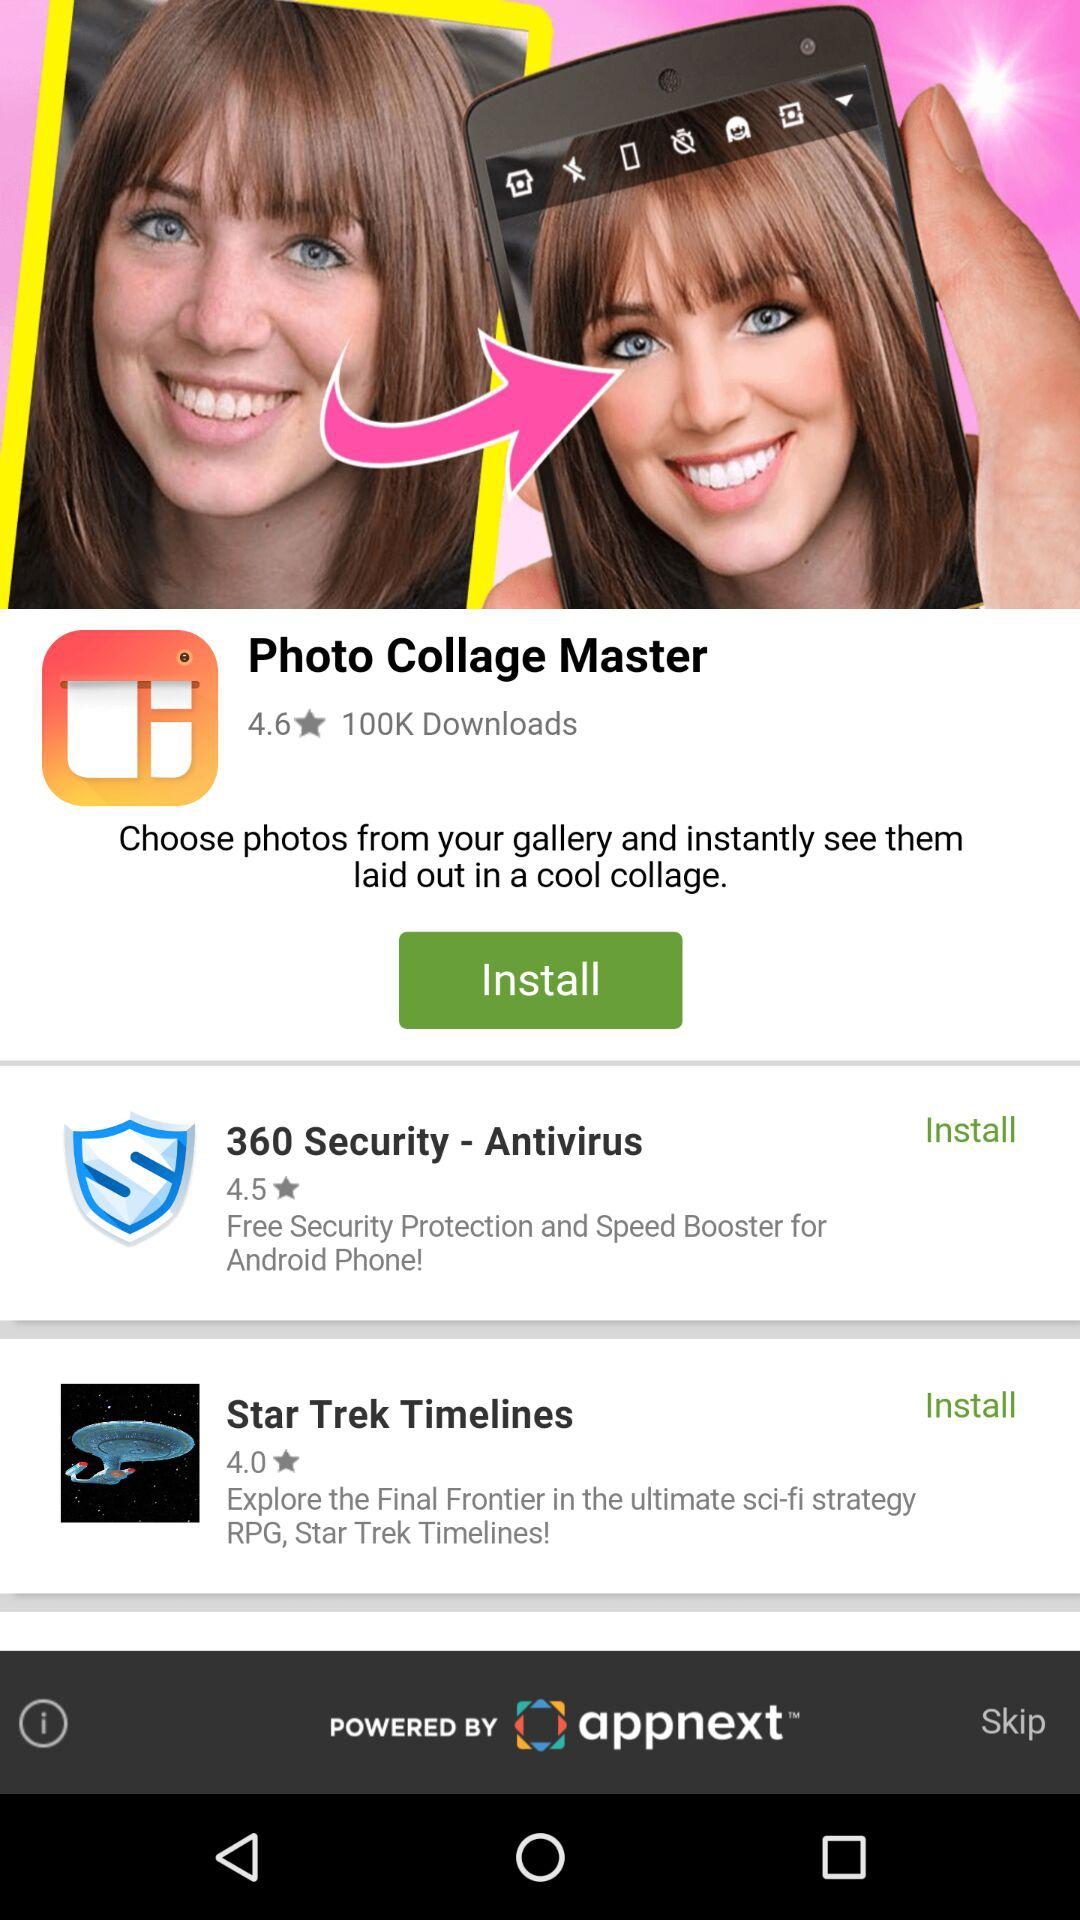What application got a 4.5 rating? The application that got a 4.5 star rating is 360 Security-Antivirus. 